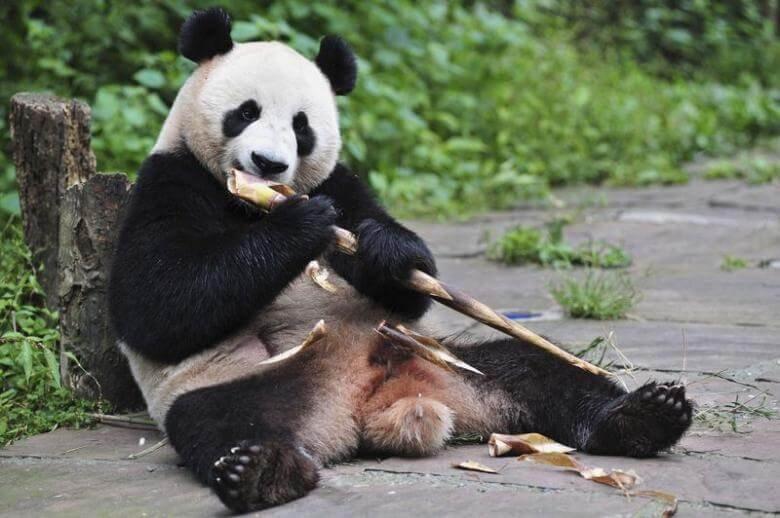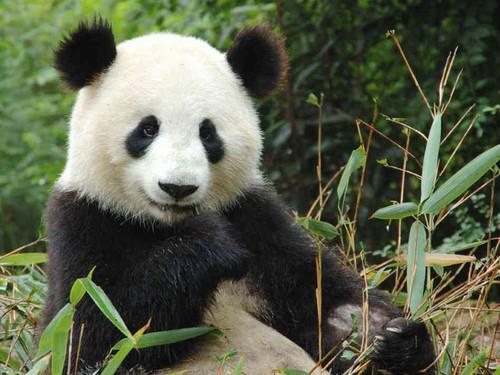The first image is the image on the left, the second image is the image on the right. Considering the images on both sides, is "An image shows a panda munching on a branch." valid? Answer yes or no. Yes. 